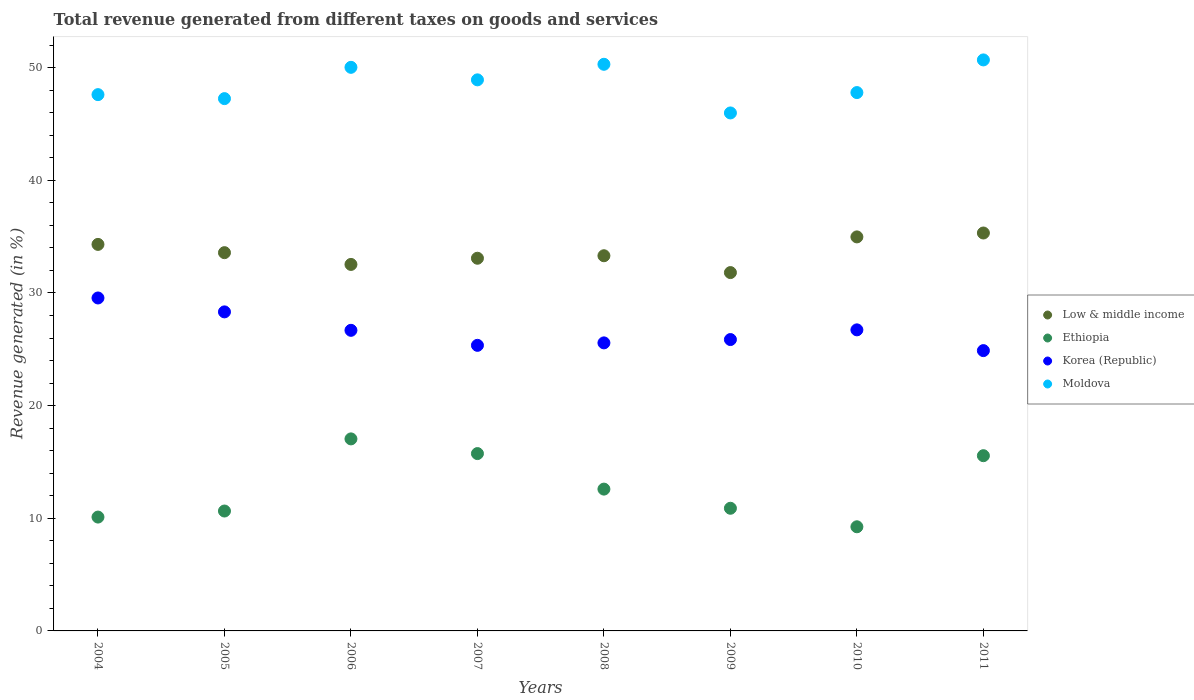What is the total revenue generated in Ethiopia in 2010?
Make the answer very short. 9.25. Across all years, what is the maximum total revenue generated in Low & middle income?
Your answer should be very brief. 35.33. Across all years, what is the minimum total revenue generated in Low & middle income?
Make the answer very short. 31.81. In which year was the total revenue generated in Low & middle income maximum?
Make the answer very short. 2011. What is the total total revenue generated in Ethiopia in the graph?
Your answer should be compact. 101.82. What is the difference between the total revenue generated in Korea (Republic) in 2006 and that in 2008?
Your response must be concise. 1.12. What is the difference between the total revenue generated in Low & middle income in 2008 and the total revenue generated in Korea (Republic) in 2007?
Provide a succinct answer. 7.95. What is the average total revenue generated in Ethiopia per year?
Your response must be concise. 12.73. In the year 2005, what is the difference between the total revenue generated in Low & middle income and total revenue generated in Korea (Republic)?
Offer a terse response. 5.26. What is the ratio of the total revenue generated in Korea (Republic) in 2009 to that in 2010?
Your response must be concise. 0.97. What is the difference between the highest and the second highest total revenue generated in Moldova?
Offer a very short reply. 0.39. What is the difference between the highest and the lowest total revenue generated in Ethiopia?
Provide a succinct answer. 7.8. Is it the case that in every year, the sum of the total revenue generated in Moldova and total revenue generated in Ethiopia  is greater than the sum of total revenue generated in Korea (Republic) and total revenue generated in Low & middle income?
Give a very brief answer. Yes. Is the total revenue generated in Ethiopia strictly greater than the total revenue generated in Moldova over the years?
Offer a very short reply. No. Is the total revenue generated in Ethiopia strictly less than the total revenue generated in Korea (Republic) over the years?
Provide a succinct answer. Yes. How many years are there in the graph?
Your response must be concise. 8. What is the difference between two consecutive major ticks on the Y-axis?
Provide a succinct answer. 10. What is the title of the graph?
Give a very brief answer. Total revenue generated from different taxes on goods and services. What is the label or title of the X-axis?
Your answer should be compact. Years. What is the label or title of the Y-axis?
Ensure brevity in your answer.  Revenue generated (in %). What is the Revenue generated (in %) of Low & middle income in 2004?
Your answer should be very brief. 34.31. What is the Revenue generated (in %) in Ethiopia in 2004?
Ensure brevity in your answer.  10.11. What is the Revenue generated (in %) in Korea (Republic) in 2004?
Offer a very short reply. 29.56. What is the Revenue generated (in %) of Moldova in 2004?
Give a very brief answer. 47.61. What is the Revenue generated (in %) of Low & middle income in 2005?
Provide a short and direct response. 33.58. What is the Revenue generated (in %) in Ethiopia in 2005?
Your answer should be compact. 10.64. What is the Revenue generated (in %) of Korea (Republic) in 2005?
Make the answer very short. 28.32. What is the Revenue generated (in %) of Moldova in 2005?
Offer a very short reply. 47.26. What is the Revenue generated (in %) in Low & middle income in 2006?
Your answer should be very brief. 32.54. What is the Revenue generated (in %) of Ethiopia in 2006?
Your answer should be very brief. 17.05. What is the Revenue generated (in %) of Korea (Republic) in 2006?
Ensure brevity in your answer.  26.69. What is the Revenue generated (in %) in Moldova in 2006?
Provide a succinct answer. 50.03. What is the Revenue generated (in %) of Low & middle income in 2007?
Provide a short and direct response. 33.08. What is the Revenue generated (in %) in Ethiopia in 2007?
Your answer should be very brief. 15.74. What is the Revenue generated (in %) of Korea (Republic) in 2007?
Offer a very short reply. 25.35. What is the Revenue generated (in %) in Moldova in 2007?
Your response must be concise. 48.92. What is the Revenue generated (in %) of Low & middle income in 2008?
Ensure brevity in your answer.  33.31. What is the Revenue generated (in %) of Ethiopia in 2008?
Offer a terse response. 12.59. What is the Revenue generated (in %) of Korea (Republic) in 2008?
Offer a terse response. 25.57. What is the Revenue generated (in %) in Moldova in 2008?
Provide a succinct answer. 50.3. What is the Revenue generated (in %) of Low & middle income in 2009?
Ensure brevity in your answer.  31.81. What is the Revenue generated (in %) of Ethiopia in 2009?
Your answer should be very brief. 10.89. What is the Revenue generated (in %) of Korea (Republic) in 2009?
Provide a short and direct response. 25.87. What is the Revenue generated (in %) in Moldova in 2009?
Your answer should be very brief. 45.98. What is the Revenue generated (in %) in Low & middle income in 2010?
Your response must be concise. 34.98. What is the Revenue generated (in %) in Ethiopia in 2010?
Give a very brief answer. 9.25. What is the Revenue generated (in %) of Korea (Republic) in 2010?
Keep it short and to the point. 26.73. What is the Revenue generated (in %) in Moldova in 2010?
Give a very brief answer. 47.79. What is the Revenue generated (in %) in Low & middle income in 2011?
Ensure brevity in your answer.  35.33. What is the Revenue generated (in %) in Ethiopia in 2011?
Offer a very short reply. 15.56. What is the Revenue generated (in %) of Korea (Republic) in 2011?
Give a very brief answer. 24.88. What is the Revenue generated (in %) in Moldova in 2011?
Ensure brevity in your answer.  50.69. Across all years, what is the maximum Revenue generated (in %) in Low & middle income?
Your response must be concise. 35.33. Across all years, what is the maximum Revenue generated (in %) of Ethiopia?
Provide a succinct answer. 17.05. Across all years, what is the maximum Revenue generated (in %) in Korea (Republic)?
Your answer should be very brief. 29.56. Across all years, what is the maximum Revenue generated (in %) of Moldova?
Offer a very short reply. 50.69. Across all years, what is the minimum Revenue generated (in %) of Low & middle income?
Offer a terse response. 31.81. Across all years, what is the minimum Revenue generated (in %) of Ethiopia?
Your answer should be very brief. 9.25. Across all years, what is the minimum Revenue generated (in %) of Korea (Republic)?
Your answer should be very brief. 24.88. Across all years, what is the minimum Revenue generated (in %) of Moldova?
Your response must be concise. 45.98. What is the total Revenue generated (in %) in Low & middle income in the graph?
Ensure brevity in your answer.  268.94. What is the total Revenue generated (in %) of Ethiopia in the graph?
Ensure brevity in your answer.  101.82. What is the total Revenue generated (in %) in Korea (Republic) in the graph?
Provide a succinct answer. 212.97. What is the total Revenue generated (in %) in Moldova in the graph?
Your answer should be compact. 388.59. What is the difference between the Revenue generated (in %) of Low & middle income in 2004 and that in 2005?
Keep it short and to the point. 0.73. What is the difference between the Revenue generated (in %) of Ethiopia in 2004 and that in 2005?
Provide a short and direct response. -0.54. What is the difference between the Revenue generated (in %) of Korea (Republic) in 2004 and that in 2005?
Offer a very short reply. 1.24. What is the difference between the Revenue generated (in %) in Moldova in 2004 and that in 2005?
Provide a short and direct response. 0.35. What is the difference between the Revenue generated (in %) of Low & middle income in 2004 and that in 2006?
Offer a terse response. 1.78. What is the difference between the Revenue generated (in %) of Ethiopia in 2004 and that in 2006?
Ensure brevity in your answer.  -6.94. What is the difference between the Revenue generated (in %) of Korea (Republic) in 2004 and that in 2006?
Give a very brief answer. 2.87. What is the difference between the Revenue generated (in %) of Moldova in 2004 and that in 2006?
Your response must be concise. -2.42. What is the difference between the Revenue generated (in %) of Low & middle income in 2004 and that in 2007?
Ensure brevity in your answer.  1.23. What is the difference between the Revenue generated (in %) of Ethiopia in 2004 and that in 2007?
Provide a short and direct response. -5.64. What is the difference between the Revenue generated (in %) in Korea (Republic) in 2004 and that in 2007?
Your answer should be compact. 4.21. What is the difference between the Revenue generated (in %) in Moldova in 2004 and that in 2007?
Ensure brevity in your answer.  -1.31. What is the difference between the Revenue generated (in %) in Ethiopia in 2004 and that in 2008?
Provide a succinct answer. -2.48. What is the difference between the Revenue generated (in %) of Korea (Republic) in 2004 and that in 2008?
Provide a short and direct response. 3.99. What is the difference between the Revenue generated (in %) of Moldova in 2004 and that in 2008?
Offer a very short reply. -2.69. What is the difference between the Revenue generated (in %) in Low & middle income in 2004 and that in 2009?
Give a very brief answer. 2.5. What is the difference between the Revenue generated (in %) in Ethiopia in 2004 and that in 2009?
Offer a terse response. -0.78. What is the difference between the Revenue generated (in %) of Korea (Republic) in 2004 and that in 2009?
Your answer should be compact. 3.69. What is the difference between the Revenue generated (in %) in Moldova in 2004 and that in 2009?
Your response must be concise. 1.63. What is the difference between the Revenue generated (in %) of Low & middle income in 2004 and that in 2010?
Offer a terse response. -0.67. What is the difference between the Revenue generated (in %) of Ethiopia in 2004 and that in 2010?
Provide a succinct answer. 0.86. What is the difference between the Revenue generated (in %) of Korea (Republic) in 2004 and that in 2010?
Your response must be concise. 2.83. What is the difference between the Revenue generated (in %) of Moldova in 2004 and that in 2010?
Offer a terse response. -0.18. What is the difference between the Revenue generated (in %) of Low & middle income in 2004 and that in 2011?
Your answer should be compact. -1.01. What is the difference between the Revenue generated (in %) of Ethiopia in 2004 and that in 2011?
Your response must be concise. -5.45. What is the difference between the Revenue generated (in %) of Korea (Republic) in 2004 and that in 2011?
Ensure brevity in your answer.  4.67. What is the difference between the Revenue generated (in %) in Moldova in 2004 and that in 2011?
Provide a short and direct response. -3.08. What is the difference between the Revenue generated (in %) of Low & middle income in 2005 and that in 2006?
Make the answer very short. 1.04. What is the difference between the Revenue generated (in %) of Ethiopia in 2005 and that in 2006?
Give a very brief answer. -6.4. What is the difference between the Revenue generated (in %) of Korea (Republic) in 2005 and that in 2006?
Offer a very short reply. 1.64. What is the difference between the Revenue generated (in %) in Moldova in 2005 and that in 2006?
Provide a short and direct response. -2.78. What is the difference between the Revenue generated (in %) of Low & middle income in 2005 and that in 2007?
Offer a very short reply. 0.5. What is the difference between the Revenue generated (in %) of Ethiopia in 2005 and that in 2007?
Give a very brief answer. -5.1. What is the difference between the Revenue generated (in %) in Korea (Republic) in 2005 and that in 2007?
Your answer should be very brief. 2.97. What is the difference between the Revenue generated (in %) in Moldova in 2005 and that in 2007?
Offer a terse response. -1.67. What is the difference between the Revenue generated (in %) of Low & middle income in 2005 and that in 2008?
Provide a short and direct response. 0.27. What is the difference between the Revenue generated (in %) of Ethiopia in 2005 and that in 2008?
Keep it short and to the point. -1.95. What is the difference between the Revenue generated (in %) in Korea (Republic) in 2005 and that in 2008?
Your answer should be very brief. 2.75. What is the difference between the Revenue generated (in %) of Moldova in 2005 and that in 2008?
Provide a short and direct response. -3.05. What is the difference between the Revenue generated (in %) of Low & middle income in 2005 and that in 2009?
Give a very brief answer. 1.77. What is the difference between the Revenue generated (in %) in Ethiopia in 2005 and that in 2009?
Provide a short and direct response. -0.25. What is the difference between the Revenue generated (in %) in Korea (Republic) in 2005 and that in 2009?
Provide a succinct answer. 2.46. What is the difference between the Revenue generated (in %) in Moldova in 2005 and that in 2009?
Your answer should be compact. 1.27. What is the difference between the Revenue generated (in %) in Low & middle income in 2005 and that in 2010?
Offer a terse response. -1.4. What is the difference between the Revenue generated (in %) in Ethiopia in 2005 and that in 2010?
Ensure brevity in your answer.  1.4. What is the difference between the Revenue generated (in %) in Korea (Republic) in 2005 and that in 2010?
Make the answer very short. 1.6. What is the difference between the Revenue generated (in %) of Moldova in 2005 and that in 2010?
Make the answer very short. -0.54. What is the difference between the Revenue generated (in %) of Low & middle income in 2005 and that in 2011?
Provide a succinct answer. -1.75. What is the difference between the Revenue generated (in %) of Ethiopia in 2005 and that in 2011?
Provide a short and direct response. -4.91. What is the difference between the Revenue generated (in %) of Korea (Republic) in 2005 and that in 2011?
Your answer should be compact. 3.44. What is the difference between the Revenue generated (in %) of Moldova in 2005 and that in 2011?
Offer a terse response. -3.44. What is the difference between the Revenue generated (in %) of Low & middle income in 2006 and that in 2007?
Provide a short and direct response. -0.55. What is the difference between the Revenue generated (in %) of Ethiopia in 2006 and that in 2007?
Keep it short and to the point. 1.3. What is the difference between the Revenue generated (in %) of Korea (Republic) in 2006 and that in 2007?
Make the answer very short. 1.33. What is the difference between the Revenue generated (in %) in Moldova in 2006 and that in 2007?
Your response must be concise. 1.11. What is the difference between the Revenue generated (in %) in Low & middle income in 2006 and that in 2008?
Make the answer very short. -0.77. What is the difference between the Revenue generated (in %) in Ethiopia in 2006 and that in 2008?
Your answer should be very brief. 4.46. What is the difference between the Revenue generated (in %) in Korea (Republic) in 2006 and that in 2008?
Make the answer very short. 1.12. What is the difference between the Revenue generated (in %) in Moldova in 2006 and that in 2008?
Provide a short and direct response. -0.27. What is the difference between the Revenue generated (in %) of Low & middle income in 2006 and that in 2009?
Give a very brief answer. 0.72. What is the difference between the Revenue generated (in %) in Ethiopia in 2006 and that in 2009?
Keep it short and to the point. 6.16. What is the difference between the Revenue generated (in %) of Korea (Republic) in 2006 and that in 2009?
Make the answer very short. 0.82. What is the difference between the Revenue generated (in %) in Moldova in 2006 and that in 2009?
Provide a short and direct response. 4.05. What is the difference between the Revenue generated (in %) of Low & middle income in 2006 and that in 2010?
Your answer should be compact. -2.44. What is the difference between the Revenue generated (in %) of Ethiopia in 2006 and that in 2010?
Make the answer very short. 7.8. What is the difference between the Revenue generated (in %) in Korea (Republic) in 2006 and that in 2010?
Your answer should be compact. -0.04. What is the difference between the Revenue generated (in %) in Moldova in 2006 and that in 2010?
Your answer should be very brief. 2.24. What is the difference between the Revenue generated (in %) of Low & middle income in 2006 and that in 2011?
Make the answer very short. -2.79. What is the difference between the Revenue generated (in %) in Ethiopia in 2006 and that in 2011?
Offer a terse response. 1.49. What is the difference between the Revenue generated (in %) in Korea (Republic) in 2006 and that in 2011?
Offer a very short reply. 1.8. What is the difference between the Revenue generated (in %) in Moldova in 2006 and that in 2011?
Make the answer very short. -0.66. What is the difference between the Revenue generated (in %) in Low & middle income in 2007 and that in 2008?
Ensure brevity in your answer.  -0.22. What is the difference between the Revenue generated (in %) in Ethiopia in 2007 and that in 2008?
Make the answer very short. 3.15. What is the difference between the Revenue generated (in %) of Korea (Republic) in 2007 and that in 2008?
Your answer should be very brief. -0.22. What is the difference between the Revenue generated (in %) of Moldova in 2007 and that in 2008?
Make the answer very short. -1.38. What is the difference between the Revenue generated (in %) in Low & middle income in 2007 and that in 2009?
Offer a very short reply. 1.27. What is the difference between the Revenue generated (in %) of Ethiopia in 2007 and that in 2009?
Your answer should be very brief. 4.85. What is the difference between the Revenue generated (in %) of Korea (Republic) in 2007 and that in 2009?
Offer a very short reply. -0.51. What is the difference between the Revenue generated (in %) of Moldova in 2007 and that in 2009?
Your response must be concise. 2.94. What is the difference between the Revenue generated (in %) of Low & middle income in 2007 and that in 2010?
Your response must be concise. -1.89. What is the difference between the Revenue generated (in %) in Ethiopia in 2007 and that in 2010?
Offer a very short reply. 6.5. What is the difference between the Revenue generated (in %) of Korea (Republic) in 2007 and that in 2010?
Your answer should be very brief. -1.37. What is the difference between the Revenue generated (in %) in Moldova in 2007 and that in 2010?
Your answer should be very brief. 1.13. What is the difference between the Revenue generated (in %) of Low & middle income in 2007 and that in 2011?
Offer a terse response. -2.24. What is the difference between the Revenue generated (in %) of Ethiopia in 2007 and that in 2011?
Provide a succinct answer. 0.19. What is the difference between the Revenue generated (in %) of Korea (Republic) in 2007 and that in 2011?
Your answer should be very brief. 0.47. What is the difference between the Revenue generated (in %) in Moldova in 2007 and that in 2011?
Your response must be concise. -1.77. What is the difference between the Revenue generated (in %) of Low & middle income in 2008 and that in 2009?
Your answer should be compact. 1.49. What is the difference between the Revenue generated (in %) in Ethiopia in 2008 and that in 2009?
Offer a very short reply. 1.7. What is the difference between the Revenue generated (in %) in Korea (Republic) in 2008 and that in 2009?
Your response must be concise. -0.3. What is the difference between the Revenue generated (in %) in Moldova in 2008 and that in 2009?
Your answer should be very brief. 4.32. What is the difference between the Revenue generated (in %) of Low & middle income in 2008 and that in 2010?
Your answer should be very brief. -1.67. What is the difference between the Revenue generated (in %) in Ethiopia in 2008 and that in 2010?
Your response must be concise. 3.34. What is the difference between the Revenue generated (in %) in Korea (Republic) in 2008 and that in 2010?
Provide a succinct answer. -1.16. What is the difference between the Revenue generated (in %) in Moldova in 2008 and that in 2010?
Ensure brevity in your answer.  2.51. What is the difference between the Revenue generated (in %) of Low & middle income in 2008 and that in 2011?
Provide a succinct answer. -2.02. What is the difference between the Revenue generated (in %) of Ethiopia in 2008 and that in 2011?
Ensure brevity in your answer.  -2.97. What is the difference between the Revenue generated (in %) in Korea (Republic) in 2008 and that in 2011?
Offer a very short reply. 0.69. What is the difference between the Revenue generated (in %) of Moldova in 2008 and that in 2011?
Your answer should be very brief. -0.39. What is the difference between the Revenue generated (in %) in Low & middle income in 2009 and that in 2010?
Offer a terse response. -3.17. What is the difference between the Revenue generated (in %) of Ethiopia in 2009 and that in 2010?
Provide a succinct answer. 1.64. What is the difference between the Revenue generated (in %) of Korea (Republic) in 2009 and that in 2010?
Make the answer very short. -0.86. What is the difference between the Revenue generated (in %) in Moldova in 2009 and that in 2010?
Keep it short and to the point. -1.81. What is the difference between the Revenue generated (in %) of Low & middle income in 2009 and that in 2011?
Your answer should be very brief. -3.51. What is the difference between the Revenue generated (in %) of Ethiopia in 2009 and that in 2011?
Make the answer very short. -4.67. What is the difference between the Revenue generated (in %) of Korea (Republic) in 2009 and that in 2011?
Your response must be concise. 0.98. What is the difference between the Revenue generated (in %) in Moldova in 2009 and that in 2011?
Provide a succinct answer. -4.71. What is the difference between the Revenue generated (in %) in Low & middle income in 2010 and that in 2011?
Ensure brevity in your answer.  -0.35. What is the difference between the Revenue generated (in %) of Ethiopia in 2010 and that in 2011?
Offer a very short reply. -6.31. What is the difference between the Revenue generated (in %) in Korea (Republic) in 2010 and that in 2011?
Offer a terse response. 1.84. What is the difference between the Revenue generated (in %) in Moldova in 2010 and that in 2011?
Provide a succinct answer. -2.9. What is the difference between the Revenue generated (in %) in Low & middle income in 2004 and the Revenue generated (in %) in Ethiopia in 2005?
Offer a very short reply. 23.67. What is the difference between the Revenue generated (in %) in Low & middle income in 2004 and the Revenue generated (in %) in Korea (Republic) in 2005?
Your answer should be compact. 5.99. What is the difference between the Revenue generated (in %) in Low & middle income in 2004 and the Revenue generated (in %) in Moldova in 2005?
Your response must be concise. -12.94. What is the difference between the Revenue generated (in %) of Ethiopia in 2004 and the Revenue generated (in %) of Korea (Republic) in 2005?
Offer a very short reply. -18.22. What is the difference between the Revenue generated (in %) of Ethiopia in 2004 and the Revenue generated (in %) of Moldova in 2005?
Give a very brief answer. -37.15. What is the difference between the Revenue generated (in %) of Korea (Republic) in 2004 and the Revenue generated (in %) of Moldova in 2005?
Your answer should be very brief. -17.7. What is the difference between the Revenue generated (in %) of Low & middle income in 2004 and the Revenue generated (in %) of Ethiopia in 2006?
Your answer should be very brief. 17.27. What is the difference between the Revenue generated (in %) in Low & middle income in 2004 and the Revenue generated (in %) in Korea (Republic) in 2006?
Offer a very short reply. 7.63. What is the difference between the Revenue generated (in %) in Low & middle income in 2004 and the Revenue generated (in %) in Moldova in 2006?
Provide a short and direct response. -15.72. What is the difference between the Revenue generated (in %) of Ethiopia in 2004 and the Revenue generated (in %) of Korea (Republic) in 2006?
Your answer should be compact. -16.58. What is the difference between the Revenue generated (in %) in Ethiopia in 2004 and the Revenue generated (in %) in Moldova in 2006?
Offer a terse response. -39.93. What is the difference between the Revenue generated (in %) in Korea (Republic) in 2004 and the Revenue generated (in %) in Moldova in 2006?
Provide a succinct answer. -20.48. What is the difference between the Revenue generated (in %) in Low & middle income in 2004 and the Revenue generated (in %) in Ethiopia in 2007?
Your response must be concise. 18.57. What is the difference between the Revenue generated (in %) of Low & middle income in 2004 and the Revenue generated (in %) of Korea (Republic) in 2007?
Your response must be concise. 8.96. What is the difference between the Revenue generated (in %) of Low & middle income in 2004 and the Revenue generated (in %) of Moldova in 2007?
Your response must be concise. -14.61. What is the difference between the Revenue generated (in %) in Ethiopia in 2004 and the Revenue generated (in %) in Korea (Republic) in 2007?
Offer a terse response. -15.25. What is the difference between the Revenue generated (in %) in Ethiopia in 2004 and the Revenue generated (in %) in Moldova in 2007?
Offer a terse response. -38.82. What is the difference between the Revenue generated (in %) in Korea (Republic) in 2004 and the Revenue generated (in %) in Moldova in 2007?
Ensure brevity in your answer.  -19.36. What is the difference between the Revenue generated (in %) in Low & middle income in 2004 and the Revenue generated (in %) in Ethiopia in 2008?
Your answer should be compact. 21.72. What is the difference between the Revenue generated (in %) in Low & middle income in 2004 and the Revenue generated (in %) in Korea (Republic) in 2008?
Your response must be concise. 8.74. What is the difference between the Revenue generated (in %) of Low & middle income in 2004 and the Revenue generated (in %) of Moldova in 2008?
Your response must be concise. -15.99. What is the difference between the Revenue generated (in %) in Ethiopia in 2004 and the Revenue generated (in %) in Korea (Republic) in 2008?
Offer a very short reply. -15.46. What is the difference between the Revenue generated (in %) in Ethiopia in 2004 and the Revenue generated (in %) in Moldova in 2008?
Keep it short and to the point. -40.2. What is the difference between the Revenue generated (in %) of Korea (Republic) in 2004 and the Revenue generated (in %) of Moldova in 2008?
Make the answer very short. -20.74. What is the difference between the Revenue generated (in %) of Low & middle income in 2004 and the Revenue generated (in %) of Ethiopia in 2009?
Your answer should be very brief. 23.42. What is the difference between the Revenue generated (in %) of Low & middle income in 2004 and the Revenue generated (in %) of Korea (Republic) in 2009?
Ensure brevity in your answer.  8.45. What is the difference between the Revenue generated (in %) of Low & middle income in 2004 and the Revenue generated (in %) of Moldova in 2009?
Provide a short and direct response. -11.67. What is the difference between the Revenue generated (in %) in Ethiopia in 2004 and the Revenue generated (in %) in Korea (Republic) in 2009?
Your answer should be very brief. -15.76. What is the difference between the Revenue generated (in %) in Ethiopia in 2004 and the Revenue generated (in %) in Moldova in 2009?
Ensure brevity in your answer.  -35.88. What is the difference between the Revenue generated (in %) of Korea (Republic) in 2004 and the Revenue generated (in %) of Moldova in 2009?
Offer a terse response. -16.43. What is the difference between the Revenue generated (in %) in Low & middle income in 2004 and the Revenue generated (in %) in Ethiopia in 2010?
Your response must be concise. 25.07. What is the difference between the Revenue generated (in %) in Low & middle income in 2004 and the Revenue generated (in %) in Korea (Republic) in 2010?
Provide a succinct answer. 7.59. What is the difference between the Revenue generated (in %) in Low & middle income in 2004 and the Revenue generated (in %) in Moldova in 2010?
Provide a succinct answer. -13.48. What is the difference between the Revenue generated (in %) in Ethiopia in 2004 and the Revenue generated (in %) in Korea (Republic) in 2010?
Make the answer very short. -16.62. What is the difference between the Revenue generated (in %) of Ethiopia in 2004 and the Revenue generated (in %) of Moldova in 2010?
Provide a succinct answer. -37.69. What is the difference between the Revenue generated (in %) in Korea (Republic) in 2004 and the Revenue generated (in %) in Moldova in 2010?
Provide a succinct answer. -18.23. What is the difference between the Revenue generated (in %) in Low & middle income in 2004 and the Revenue generated (in %) in Ethiopia in 2011?
Your answer should be very brief. 18.76. What is the difference between the Revenue generated (in %) in Low & middle income in 2004 and the Revenue generated (in %) in Korea (Republic) in 2011?
Your answer should be compact. 9.43. What is the difference between the Revenue generated (in %) of Low & middle income in 2004 and the Revenue generated (in %) of Moldova in 2011?
Keep it short and to the point. -16.38. What is the difference between the Revenue generated (in %) of Ethiopia in 2004 and the Revenue generated (in %) of Korea (Republic) in 2011?
Keep it short and to the point. -14.78. What is the difference between the Revenue generated (in %) of Ethiopia in 2004 and the Revenue generated (in %) of Moldova in 2011?
Offer a very short reply. -40.58. What is the difference between the Revenue generated (in %) of Korea (Republic) in 2004 and the Revenue generated (in %) of Moldova in 2011?
Provide a short and direct response. -21.13. What is the difference between the Revenue generated (in %) in Low & middle income in 2005 and the Revenue generated (in %) in Ethiopia in 2006?
Offer a terse response. 16.53. What is the difference between the Revenue generated (in %) in Low & middle income in 2005 and the Revenue generated (in %) in Korea (Republic) in 2006?
Keep it short and to the point. 6.89. What is the difference between the Revenue generated (in %) of Low & middle income in 2005 and the Revenue generated (in %) of Moldova in 2006?
Provide a succinct answer. -16.45. What is the difference between the Revenue generated (in %) of Ethiopia in 2005 and the Revenue generated (in %) of Korea (Republic) in 2006?
Your response must be concise. -16.04. What is the difference between the Revenue generated (in %) of Ethiopia in 2005 and the Revenue generated (in %) of Moldova in 2006?
Offer a very short reply. -39.39. What is the difference between the Revenue generated (in %) of Korea (Republic) in 2005 and the Revenue generated (in %) of Moldova in 2006?
Ensure brevity in your answer.  -21.71. What is the difference between the Revenue generated (in %) in Low & middle income in 2005 and the Revenue generated (in %) in Ethiopia in 2007?
Ensure brevity in your answer.  17.84. What is the difference between the Revenue generated (in %) of Low & middle income in 2005 and the Revenue generated (in %) of Korea (Republic) in 2007?
Your answer should be very brief. 8.23. What is the difference between the Revenue generated (in %) of Low & middle income in 2005 and the Revenue generated (in %) of Moldova in 2007?
Offer a terse response. -15.34. What is the difference between the Revenue generated (in %) in Ethiopia in 2005 and the Revenue generated (in %) in Korea (Republic) in 2007?
Offer a very short reply. -14.71. What is the difference between the Revenue generated (in %) in Ethiopia in 2005 and the Revenue generated (in %) in Moldova in 2007?
Ensure brevity in your answer.  -38.28. What is the difference between the Revenue generated (in %) of Korea (Republic) in 2005 and the Revenue generated (in %) of Moldova in 2007?
Offer a terse response. -20.6. What is the difference between the Revenue generated (in %) in Low & middle income in 2005 and the Revenue generated (in %) in Ethiopia in 2008?
Offer a terse response. 20.99. What is the difference between the Revenue generated (in %) in Low & middle income in 2005 and the Revenue generated (in %) in Korea (Republic) in 2008?
Your answer should be very brief. 8.01. What is the difference between the Revenue generated (in %) in Low & middle income in 2005 and the Revenue generated (in %) in Moldova in 2008?
Make the answer very short. -16.72. What is the difference between the Revenue generated (in %) in Ethiopia in 2005 and the Revenue generated (in %) in Korea (Republic) in 2008?
Keep it short and to the point. -14.93. What is the difference between the Revenue generated (in %) in Ethiopia in 2005 and the Revenue generated (in %) in Moldova in 2008?
Your response must be concise. -39.66. What is the difference between the Revenue generated (in %) in Korea (Republic) in 2005 and the Revenue generated (in %) in Moldova in 2008?
Your answer should be very brief. -21.98. What is the difference between the Revenue generated (in %) in Low & middle income in 2005 and the Revenue generated (in %) in Ethiopia in 2009?
Your response must be concise. 22.69. What is the difference between the Revenue generated (in %) in Low & middle income in 2005 and the Revenue generated (in %) in Korea (Republic) in 2009?
Your response must be concise. 7.71. What is the difference between the Revenue generated (in %) in Low & middle income in 2005 and the Revenue generated (in %) in Moldova in 2009?
Keep it short and to the point. -12.4. What is the difference between the Revenue generated (in %) in Ethiopia in 2005 and the Revenue generated (in %) in Korea (Republic) in 2009?
Make the answer very short. -15.22. What is the difference between the Revenue generated (in %) in Ethiopia in 2005 and the Revenue generated (in %) in Moldova in 2009?
Offer a very short reply. -35.34. What is the difference between the Revenue generated (in %) of Korea (Republic) in 2005 and the Revenue generated (in %) of Moldova in 2009?
Ensure brevity in your answer.  -17.66. What is the difference between the Revenue generated (in %) in Low & middle income in 2005 and the Revenue generated (in %) in Ethiopia in 2010?
Ensure brevity in your answer.  24.33. What is the difference between the Revenue generated (in %) of Low & middle income in 2005 and the Revenue generated (in %) of Korea (Republic) in 2010?
Provide a short and direct response. 6.85. What is the difference between the Revenue generated (in %) of Low & middle income in 2005 and the Revenue generated (in %) of Moldova in 2010?
Offer a very short reply. -14.21. What is the difference between the Revenue generated (in %) of Ethiopia in 2005 and the Revenue generated (in %) of Korea (Republic) in 2010?
Your answer should be compact. -16.08. What is the difference between the Revenue generated (in %) of Ethiopia in 2005 and the Revenue generated (in %) of Moldova in 2010?
Offer a very short reply. -37.15. What is the difference between the Revenue generated (in %) in Korea (Republic) in 2005 and the Revenue generated (in %) in Moldova in 2010?
Your response must be concise. -19.47. What is the difference between the Revenue generated (in %) in Low & middle income in 2005 and the Revenue generated (in %) in Ethiopia in 2011?
Provide a short and direct response. 18.02. What is the difference between the Revenue generated (in %) in Low & middle income in 2005 and the Revenue generated (in %) in Korea (Republic) in 2011?
Give a very brief answer. 8.7. What is the difference between the Revenue generated (in %) of Low & middle income in 2005 and the Revenue generated (in %) of Moldova in 2011?
Your answer should be compact. -17.11. What is the difference between the Revenue generated (in %) in Ethiopia in 2005 and the Revenue generated (in %) in Korea (Republic) in 2011?
Give a very brief answer. -14.24. What is the difference between the Revenue generated (in %) in Ethiopia in 2005 and the Revenue generated (in %) in Moldova in 2011?
Your response must be concise. -40.05. What is the difference between the Revenue generated (in %) of Korea (Republic) in 2005 and the Revenue generated (in %) of Moldova in 2011?
Your response must be concise. -22.37. What is the difference between the Revenue generated (in %) of Low & middle income in 2006 and the Revenue generated (in %) of Ethiopia in 2007?
Your answer should be very brief. 16.79. What is the difference between the Revenue generated (in %) of Low & middle income in 2006 and the Revenue generated (in %) of Korea (Republic) in 2007?
Keep it short and to the point. 7.18. What is the difference between the Revenue generated (in %) in Low & middle income in 2006 and the Revenue generated (in %) in Moldova in 2007?
Keep it short and to the point. -16.39. What is the difference between the Revenue generated (in %) in Ethiopia in 2006 and the Revenue generated (in %) in Korea (Republic) in 2007?
Your answer should be very brief. -8.31. What is the difference between the Revenue generated (in %) in Ethiopia in 2006 and the Revenue generated (in %) in Moldova in 2007?
Your answer should be compact. -31.87. What is the difference between the Revenue generated (in %) of Korea (Republic) in 2006 and the Revenue generated (in %) of Moldova in 2007?
Provide a short and direct response. -22.24. What is the difference between the Revenue generated (in %) of Low & middle income in 2006 and the Revenue generated (in %) of Ethiopia in 2008?
Give a very brief answer. 19.95. What is the difference between the Revenue generated (in %) of Low & middle income in 2006 and the Revenue generated (in %) of Korea (Republic) in 2008?
Offer a terse response. 6.96. What is the difference between the Revenue generated (in %) of Low & middle income in 2006 and the Revenue generated (in %) of Moldova in 2008?
Your answer should be compact. -17.77. What is the difference between the Revenue generated (in %) of Ethiopia in 2006 and the Revenue generated (in %) of Korea (Republic) in 2008?
Your answer should be very brief. -8.52. What is the difference between the Revenue generated (in %) in Ethiopia in 2006 and the Revenue generated (in %) in Moldova in 2008?
Give a very brief answer. -33.26. What is the difference between the Revenue generated (in %) of Korea (Republic) in 2006 and the Revenue generated (in %) of Moldova in 2008?
Ensure brevity in your answer.  -23.62. What is the difference between the Revenue generated (in %) in Low & middle income in 2006 and the Revenue generated (in %) in Ethiopia in 2009?
Your answer should be very brief. 21.65. What is the difference between the Revenue generated (in %) in Low & middle income in 2006 and the Revenue generated (in %) in Korea (Republic) in 2009?
Give a very brief answer. 6.67. What is the difference between the Revenue generated (in %) of Low & middle income in 2006 and the Revenue generated (in %) of Moldova in 2009?
Offer a very short reply. -13.45. What is the difference between the Revenue generated (in %) of Ethiopia in 2006 and the Revenue generated (in %) of Korea (Republic) in 2009?
Keep it short and to the point. -8.82. What is the difference between the Revenue generated (in %) in Ethiopia in 2006 and the Revenue generated (in %) in Moldova in 2009?
Your response must be concise. -28.94. What is the difference between the Revenue generated (in %) in Korea (Republic) in 2006 and the Revenue generated (in %) in Moldova in 2009?
Your answer should be compact. -19.3. What is the difference between the Revenue generated (in %) in Low & middle income in 2006 and the Revenue generated (in %) in Ethiopia in 2010?
Provide a short and direct response. 23.29. What is the difference between the Revenue generated (in %) of Low & middle income in 2006 and the Revenue generated (in %) of Korea (Republic) in 2010?
Provide a succinct answer. 5.81. What is the difference between the Revenue generated (in %) in Low & middle income in 2006 and the Revenue generated (in %) in Moldova in 2010?
Provide a short and direct response. -15.26. What is the difference between the Revenue generated (in %) of Ethiopia in 2006 and the Revenue generated (in %) of Korea (Republic) in 2010?
Provide a short and direct response. -9.68. What is the difference between the Revenue generated (in %) in Ethiopia in 2006 and the Revenue generated (in %) in Moldova in 2010?
Your response must be concise. -30.74. What is the difference between the Revenue generated (in %) in Korea (Republic) in 2006 and the Revenue generated (in %) in Moldova in 2010?
Your response must be concise. -21.11. What is the difference between the Revenue generated (in %) in Low & middle income in 2006 and the Revenue generated (in %) in Ethiopia in 2011?
Give a very brief answer. 16.98. What is the difference between the Revenue generated (in %) in Low & middle income in 2006 and the Revenue generated (in %) in Korea (Republic) in 2011?
Your response must be concise. 7.65. What is the difference between the Revenue generated (in %) in Low & middle income in 2006 and the Revenue generated (in %) in Moldova in 2011?
Provide a succinct answer. -18.16. What is the difference between the Revenue generated (in %) in Ethiopia in 2006 and the Revenue generated (in %) in Korea (Republic) in 2011?
Offer a very short reply. -7.84. What is the difference between the Revenue generated (in %) of Ethiopia in 2006 and the Revenue generated (in %) of Moldova in 2011?
Offer a terse response. -33.64. What is the difference between the Revenue generated (in %) in Korea (Republic) in 2006 and the Revenue generated (in %) in Moldova in 2011?
Offer a very short reply. -24. What is the difference between the Revenue generated (in %) in Low & middle income in 2007 and the Revenue generated (in %) in Ethiopia in 2008?
Provide a succinct answer. 20.5. What is the difference between the Revenue generated (in %) in Low & middle income in 2007 and the Revenue generated (in %) in Korea (Republic) in 2008?
Provide a short and direct response. 7.51. What is the difference between the Revenue generated (in %) in Low & middle income in 2007 and the Revenue generated (in %) in Moldova in 2008?
Your answer should be compact. -17.22. What is the difference between the Revenue generated (in %) in Ethiopia in 2007 and the Revenue generated (in %) in Korea (Republic) in 2008?
Offer a terse response. -9.83. What is the difference between the Revenue generated (in %) in Ethiopia in 2007 and the Revenue generated (in %) in Moldova in 2008?
Your response must be concise. -34.56. What is the difference between the Revenue generated (in %) in Korea (Republic) in 2007 and the Revenue generated (in %) in Moldova in 2008?
Keep it short and to the point. -24.95. What is the difference between the Revenue generated (in %) in Low & middle income in 2007 and the Revenue generated (in %) in Ethiopia in 2009?
Your answer should be compact. 22.2. What is the difference between the Revenue generated (in %) in Low & middle income in 2007 and the Revenue generated (in %) in Korea (Republic) in 2009?
Make the answer very short. 7.22. What is the difference between the Revenue generated (in %) in Low & middle income in 2007 and the Revenue generated (in %) in Moldova in 2009?
Ensure brevity in your answer.  -12.9. What is the difference between the Revenue generated (in %) of Ethiopia in 2007 and the Revenue generated (in %) of Korea (Republic) in 2009?
Offer a terse response. -10.12. What is the difference between the Revenue generated (in %) in Ethiopia in 2007 and the Revenue generated (in %) in Moldova in 2009?
Offer a very short reply. -30.24. What is the difference between the Revenue generated (in %) in Korea (Republic) in 2007 and the Revenue generated (in %) in Moldova in 2009?
Your answer should be very brief. -20.63. What is the difference between the Revenue generated (in %) in Low & middle income in 2007 and the Revenue generated (in %) in Ethiopia in 2010?
Offer a terse response. 23.84. What is the difference between the Revenue generated (in %) of Low & middle income in 2007 and the Revenue generated (in %) of Korea (Republic) in 2010?
Ensure brevity in your answer.  6.36. What is the difference between the Revenue generated (in %) of Low & middle income in 2007 and the Revenue generated (in %) of Moldova in 2010?
Your response must be concise. -14.71. What is the difference between the Revenue generated (in %) in Ethiopia in 2007 and the Revenue generated (in %) in Korea (Republic) in 2010?
Your answer should be compact. -10.98. What is the difference between the Revenue generated (in %) of Ethiopia in 2007 and the Revenue generated (in %) of Moldova in 2010?
Ensure brevity in your answer.  -32.05. What is the difference between the Revenue generated (in %) in Korea (Republic) in 2007 and the Revenue generated (in %) in Moldova in 2010?
Offer a very short reply. -22.44. What is the difference between the Revenue generated (in %) of Low & middle income in 2007 and the Revenue generated (in %) of Ethiopia in 2011?
Your response must be concise. 17.53. What is the difference between the Revenue generated (in %) of Low & middle income in 2007 and the Revenue generated (in %) of Korea (Republic) in 2011?
Provide a succinct answer. 8.2. What is the difference between the Revenue generated (in %) of Low & middle income in 2007 and the Revenue generated (in %) of Moldova in 2011?
Your response must be concise. -17.61. What is the difference between the Revenue generated (in %) in Ethiopia in 2007 and the Revenue generated (in %) in Korea (Republic) in 2011?
Provide a succinct answer. -9.14. What is the difference between the Revenue generated (in %) in Ethiopia in 2007 and the Revenue generated (in %) in Moldova in 2011?
Offer a terse response. -34.95. What is the difference between the Revenue generated (in %) in Korea (Republic) in 2007 and the Revenue generated (in %) in Moldova in 2011?
Offer a terse response. -25.34. What is the difference between the Revenue generated (in %) of Low & middle income in 2008 and the Revenue generated (in %) of Ethiopia in 2009?
Give a very brief answer. 22.42. What is the difference between the Revenue generated (in %) in Low & middle income in 2008 and the Revenue generated (in %) in Korea (Republic) in 2009?
Give a very brief answer. 7.44. What is the difference between the Revenue generated (in %) in Low & middle income in 2008 and the Revenue generated (in %) in Moldova in 2009?
Give a very brief answer. -12.68. What is the difference between the Revenue generated (in %) of Ethiopia in 2008 and the Revenue generated (in %) of Korea (Republic) in 2009?
Offer a terse response. -13.28. What is the difference between the Revenue generated (in %) of Ethiopia in 2008 and the Revenue generated (in %) of Moldova in 2009?
Provide a short and direct response. -33.39. What is the difference between the Revenue generated (in %) in Korea (Republic) in 2008 and the Revenue generated (in %) in Moldova in 2009?
Give a very brief answer. -20.41. What is the difference between the Revenue generated (in %) in Low & middle income in 2008 and the Revenue generated (in %) in Ethiopia in 2010?
Your answer should be very brief. 24.06. What is the difference between the Revenue generated (in %) in Low & middle income in 2008 and the Revenue generated (in %) in Korea (Republic) in 2010?
Provide a short and direct response. 6.58. What is the difference between the Revenue generated (in %) of Low & middle income in 2008 and the Revenue generated (in %) of Moldova in 2010?
Your answer should be very brief. -14.49. What is the difference between the Revenue generated (in %) in Ethiopia in 2008 and the Revenue generated (in %) in Korea (Republic) in 2010?
Make the answer very short. -14.14. What is the difference between the Revenue generated (in %) in Ethiopia in 2008 and the Revenue generated (in %) in Moldova in 2010?
Keep it short and to the point. -35.2. What is the difference between the Revenue generated (in %) in Korea (Republic) in 2008 and the Revenue generated (in %) in Moldova in 2010?
Your answer should be compact. -22.22. What is the difference between the Revenue generated (in %) of Low & middle income in 2008 and the Revenue generated (in %) of Ethiopia in 2011?
Offer a terse response. 17.75. What is the difference between the Revenue generated (in %) of Low & middle income in 2008 and the Revenue generated (in %) of Korea (Republic) in 2011?
Provide a short and direct response. 8.42. What is the difference between the Revenue generated (in %) in Low & middle income in 2008 and the Revenue generated (in %) in Moldova in 2011?
Make the answer very short. -17.38. What is the difference between the Revenue generated (in %) of Ethiopia in 2008 and the Revenue generated (in %) of Korea (Republic) in 2011?
Your answer should be very brief. -12.3. What is the difference between the Revenue generated (in %) of Ethiopia in 2008 and the Revenue generated (in %) of Moldova in 2011?
Ensure brevity in your answer.  -38.1. What is the difference between the Revenue generated (in %) of Korea (Republic) in 2008 and the Revenue generated (in %) of Moldova in 2011?
Your response must be concise. -25.12. What is the difference between the Revenue generated (in %) of Low & middle income in 2009 and the Revenue generated (in %) of Ethiopia in 2010?
Keep it short and to the point. 22.57. What is the difference between the Revenue generated (in %) in Low & middle income in 2009 and the Revenue generated (in %) in Korea (Republic) in 2010?
Your answer should be very brief. 5.08. What is the difference between the Revenue generated (in %) in Low & middle income in 2009 and the Revenue generated (in %) in Moldova in 2010?
Ensure brevity in your answer.  -15.98. What is the difference between the Revenue generated (in %) of Ethiopia in 2009 and the Revenue generated (in %) of Korea (Republic) in 2010?
Provide a succinct answer. -15.84. What is the difference between the Revenue generated (in %) of Ethiopia in 2009 and the Revenue generated (in %) of Moldova in 2010?
Offer a terse response. -36.9. What is the difference between the Revenue generated (in %) in Korea (Republic) in 2009 and the Revenue generated (in %) in Moldova in 2010?
Make the answer very short. -21.93. What is the difference between the Revenue generated (in %) in Low & middle income in 2009 and the Revenue generated (in %) in Ethiopia in 2011?
Provide a succinct answer. 16.26. What is the difference between the Revenue generated (in %) in Low & middle income in 2009 and the Revenue generated (in %) in Korea (Republic) in 2011?
Your answer should be compact. 6.93. What is the difference between the Revenue generated (in %) of Low & middle income in 2009 and the Revenue generated (in %) of Moldova in 2011?
Your answer should be compact. -18.88. What is the difference between the Revenue generated (in %) in Ethiopia in 2009 and the Revenue generated (in %) in Korea (Republic) in 2011?
Your response must be concise. -14. What is the difference between the Revenue generated (in %) of Ethiopia in 2009 and the Revenue generated (in %) of Moldova in 2011?
Your answer should be compact. -39.8. What is the difference between the Revenue generated (in %) in Korea (Republic) in 2009 and the Revenue generated (in %) in Moldova in 2011?
Make the answer very short. -24.82. What is the difference between the Revenue generated (in %) of Low & middle income in 2010 and the Revenue generated (in %) of Ethiopia in 2011?
Keep it short and to the point. 19.42. What is the difference between the Revenue generated (in %) in Low & middle income in 2010 and the Revenue generated (in %) in Korea (Republic) in 2011?
Ensure brevity in your answer.  10.09. What is the difference between the Revenue generated (in %) of Low & middle income in 2010 and the Revenue generated (in %) of Moldova in 2011?
Your answer should be very brief. -15.71. What is the difference between the Revenue generated (in %) of Ethiopia in 2010 and the Revenue generated (in %) of Korea (Republic) in 2011?
Your answer should be very brief. -15.64. What is the difference between the Revenue generated (in %) of Ethiopia in 2010 and the Revenue generated (in %) of Moldova in 2011?
Offer a terse response. -41.45. What is the difference between the Revenue generated (in %) in Korea (Republic) in 2010 and the Revenue generated (in %) in Moldova in 2011?
Provide a succinct answer. -23.96. What is the average Revenue generated (in %) of Low & middle income per year?
Give a very brief answer. 33.62. What is the average Revenue generated (in %) in Ethiopia per year?
Provide a succinct answer. 12.73. What is the average Revenue generated (in %) of Korea (Republic) per year?
Give a very brief answer. 26.62. What is the average Revenue generated (in %) of Moldova per year?
Provide a short and direct response. 48.57. In the year 2004, what is the difference between the Revenue generated (in %) of Low & middle income and Revenue generated (in %) of Ethiopia?
Offer a very short reply. 24.21. In the year 2004, what is the difference between the Revenue generated (in %) in Low & middle income and Revenue generated (in %) in Korea (Republic)?
Make the answer very short. 4.76. In the year 2004, what is the difference between the Revenue generated (in %) in Low & middle income and Revenue generated (in %) in Moldova?
Provide a short and direct response. -13.3. In the year 2004, what is the difference between the Revenue generated (in %) of Ethiopia and Revenue generated (in %) of Korea (Republic)?
Give a very brief answer. -19.45. In the year 2004, what is the difference between the Revenue generated (in %) in Ethiopia and Revenue generated (in %) in Moldova?
Provide a succinct answer. -37.5. In the year 2004, what is the difference between the Revenue generated (in %) in Korea (Republic) and Revenue generated (in %) in Moldova?
Your answer should be compact. -18.05. In the year 2005, what is the difference between the Revenue generated (in %) of Low & middle income and Revenue generated (in %) of Ethiopia?
Your answer should be compact. 22.94. In the year 2005, what is the difference between the Revenue generated (in %) in Low & middle income and Revenue generated (in %) in Korea (Republic)?
Offer a terse response. 5.26. In the year 2005, what is the difference between the Revenue generated (in %) of Low & middle income and Revenue generated (in %) of Moldova?
Provide a succinct answer. -13.68. In the year 2005, what is the difference between the Revenue generated (in %) in Ethiopia and Revenue generated (in %) in Korea (Republic)?
Make the answer very short. -17.68. In the year 2005, what is the difference between the Revenue generated (in %) in Ethiopia and Revenue generated (in %) in Moldova?
Offer a terse response. -36.61. In the year 2005, what is the difference between the Revenue generated (in %) of Korea (Republic) and Revenue generated (in %) of Moldova?
Provide a succinct answer. -18.93. In the year 2006, what is the difference between the Revenue generated (in %) of Low & middle income and Revenue generated (in %) of Ethiopia?
Provide a succinct answer. 15.49. In the year 2006, what is the difference between the Revenue generated (in %) of Low & middle income and Revenue generated (in %) of Korea (Republic)?
Offer a terse response. 5.85. In the year 2006, what is the difference between the Revenue generated (in %) of Low & middle income and Revenue generated (in %) of Moldova?
Provide a succinct answer. -17.5. In the year 2006, what is the difference between the Revenue generated (in %) of Ethiopia and Revenue generated (in %) of Korea (Republic)?
Offer a terse response. -9.64. In the year 2006, what is the difference between the Revenue generated (in %) of Ethiopia and Revenue generated (in %) of Moldova?
Ensure brevity in your answer.  -32.99. In the year 2006, what is the difference between the Revenue generated (in %) in Korea (Republic) and Revenue generated (in %) in Moldova?
Keep it short and to the point. -23.35. In the year 2007, what is the difference between the Revenue generated (in %) in Low & middle income and Revenue generated (in %) in Ethiopia?
Your answer should be very brief. 17.34. In the year 2007, what is the difference between the Revenue generated (in %) in Low & middle income and Revenue generated (in %) in Korea (Republic)?
Your response must be concise. 7.73. In the year 2007, what is the difference between the Revenue generated (in %) of Low & middle income and Revenue generated (in %) of Moldova?
Offer a terse response. -15.84. In the year 2007, what is the difference between the Revenue generated (in %) of Ethiopia and Revenue generated (in %) of Korea (Republic)?
Your answer should be very brief. -9.61. In the year 2007, what is the difference between the Revenue generated (in %) of Ethiopia and Revenue generated (in %) of Moldova?
Your answer should be very brief. -33.18. In the year 2007, what is the difference between the Revenue generated (in %) in Korea (Republic) and Revenue generated (in %) in Moldova?
Offer a very short reply. -23.57. In the year 2008, what is the difference between the Revenue generated (in %) in Low & middle income and Revenue generated (in %) in Ethiopia?
Ensure brevity in your answer.  20.72. In the year 2008, what is the difference between the Revenue generated (in %) in Low & middle income and Revenue generated (in %) in Korea (Republic)?
Ensure brevity in your answer.  7.74. In the year 2008, what is the difference between the Revenue generated (in %) in Low & middle income and Revenue generated (in %) in Moldova?
Your answer should be very brief. -17. In the year 2008, what is the difference between the Revenue generated (in %) of Ethiopia and Revenue generated (in %) of Korea (Republic)?
Ensure brevity in your answer.  -12.98. In the year 2008, what is the difference between the Revenue generated (in %) of Ethiopia and Revenue generated (in %) of Moldova?
Give a very brief answer. -37.71. In the year 2008, what is the difference between the Revenue generated (in %) in Korea (Republic) and Revenue generated (in %) in Moldova?
Provide a succinct answer. -24.73. In the year 2009, what is the difference between the Revenue generated (in %) of Low & middle income and Revenue generated (in %) of Ethiopia?
Offer a very short reply. 20.92. In the year 2009, what is the difference between the Revenue generated (in %) in Low & middle income and Revenue generated (in %) in Korea (Republic)?
Give a very brief answer. 5.95. In the year 2009, what is the difference between the Revenue generated (in %) in Low & middle income and Revenue generated (in %) in Moldova?
Your answer should be compact. -14.17. In the year 2009, what is the difference between the Revenue generated (in %) of Ethiopia and Revenue generated (in %) of Korea (Republic)?
Make the answer very short. -14.98. In the year 2009, what is the difference between the Revenue generated (in %) in Ethiopia and Revenue generated (in %) in Moldova?
Your answer should be very brief. -35.09. In the year 2009, what is the difference between the Revenue generated (in %) in Korea (Republic) and Revenue generated (in %) in Moldova?
Your answer should be compact. -20.12. In the year 2010, what is the difference between the Revenue generated (in %) in Low & middle income and Revenue generated (in %) in Ethiopia?
Your response must be concise. 25.73. In the year 2010, what is the difference between the Revenue generated (in %) of Low & middle income and Revenue generated (in %) of Korea (Republic)?
Your answer should be compact. 8.25. In the year 2010, what is the difference between the Revenue generated (in %) of Low & middle income and Revenue generated (in %) of Moldova?
Make the answer very short. -12.81. In the year 2010, what is the difference between the Revenue generated (in %) of Ethiopia and Revenue generated (in %) of Korea (Republic)?
Your response must be concise. -17.48. In the year 2010, what is the difference between the Revenue generated (in %) of Ethiopia and Revenue generated (in %) of Moldova?
Offer a terse response. -38.55. In the year 2010, what is the difference between the Revenue generated (in %) in Korea (Republic) and Revenue generated (in %) in Moldova?
Make the answer very short. -21.07. In the year 2011, what is the difference between the Revenue generated (in %) of Low & middle income and Revenue generated (in %) of Ethiopia?
Keep it short and to the point. 19.77. In the year 2011, what is the difference between the Revenue generated (in %) of Low & middle income and Revenue generated (in %) of Korea (Republic)?
Provide a succinct answer. 10.44. In the year 2011, what is the difference between the Revenue generated (in %) in Low & middle income and Revenue generated (in %) in Moldova?
Offer a terse response. -15.37. In the year 2011, what is the difference between the Revenue generated (in %) of Ethiopia and Revenue generated (in %) of Korea (Republic)?
Your answer should be very brief. -9.33. In the year 2011, what is the difference between the Revenue generated (in %) in Ethiopia and Revenue generated (in %) in Moldova?
Provide a succinct answer. -35.14. In the year 2011, what is the difference between the Revenue generated (in %) in Korea (Republic) and Revenue generated (in %) in Moldova?
Provide a short and direct response. -25.81. What is the ratio of the Revenue generated (in %) in Low & middle income in 2004 to that in 2005?
Your answer should be compact. 1.02. What is the ratio of the Revenue generated (in %) in Ethiopia in 2004 to that in 2005?
Make the answer very short. 0.95. What is the ratio of the Revenue generated (in %) in Korea (Republic) in 2004 to that in 2005?
Make the answer very short. 1.04. What is the ratio of the Revenue generated (in %) of Moldova in 2004 to that in 2005?
Offer a terse response. 1.01. What is the ratio of the Revenue generated (in %) in Low & middle income in 2004 to that in 2006?
Offer a very short reply. 1.05. What is the ratio of the Revenue generated (in %) of Ethiopia in 2004 to that in 2006?
Your answer should be very brief. 0.59. What is the ratio of the Revenue generated (in %) of Korea (Republic) in 2004 to that in 2006?
Ensure brevity in your answer.  1.11. What is the ratio of the Revenue generated (in %) in Moldova in 2004 to that in 2006?
Provide a succinct answer. 0.95. What is the ratio of the Revenue generated (in %) in Low & middle income in 2004 to that in 2007?
Ensure brevity in your answer.  1.04. What is the ratio of the Revenue generated (in %) in Ethiopia in 2004 to that in 2007?
Keep it short and to the point. 0.64. What is the ratio of the Revenue generated (in %) of Korea (Republic) in 2004 to that in 2007?
Ensure brevity in your answer.  1.17. What is the ratio of the Revenue generated (in %) in Moldova in 2004 to that in 2007?
Your response must be concise. 0.97. What is the ratio of the Revenue generated (in %) in Low & middle income in 2004 to that in 2008?
Provide a short and direct response. 1.03. What is the ratio of the Revenue generated (in %) of Ethiopia in 2004 to that in 2008?
Your response must be concise. 0.8. What is the ratio of the Revenue generated (in %) in Korea (Republic) in 2004 to that in 2008?
Your answer should be compact. 1.16. What is the ratio of the Revenue generated (in %) in Moldova in 2004 to that in 2008?
Offer a terse response. 0.95. What is the ratio of the Revenue generated (in %) in Low & middle income in 2004 to that in 2009?
Make the answer very short. 1.08. What is the ratio of the Revenue generated (in %) in Ethiopia in 2004 to that in 2009?
Keep it short and to the point. 0.93. What is the ratio of the Revenue generated (in %) of Korea (Republic) in 2004 to that in 2009?
Provide a succinct answer. 1.14. What is the ratio of the Revenue generated (in %) in Moldova in 2004 to that in 2009?
Your answer should be compact. 1.04. What is the ratio of the Revenue generated (in %) in Ethiopia in 2004 to that in 2010?
Make the answer very short. 1.09. What is the ratio of the Revenue generated (in %) of Korea (Republic) in 2004 to that in 2010?
Your answer should be very brief. 1.11. What is the ratio of the Revenue generated (in %) of Low & middle income in 2004 to that in 2011?
Ensure brevity in your answer.  0.97. What is the ratio of the Revenue generated (in %) in Ethiopia in 2004 to that in 2011?
Your answer should be very brief. 0.65. What is the ratio of the Revenue generated (in %) in Korea (Republic) in 2004 to that in 2011?
Your response must be concise. 1.19. What is the ratio of the Revenue generated (in %) in Moldova in 2004 to that in 2011?
Provide a succinct answer. 0.94. What is the ratio of the Revenue generated (in %) of Low & middle income in 2005 to that in 2006?
Provide a succinct answer. 1.03. What is the ratio of the Revenue generated (in %) of Ethiopia in 2005 to that in 2006?
Offer a terse response. 0.62. What is the ratio of the Revenue generated (in %) in Korea (Republic) in 2005 to that in 2006?
Provide a succinct answer. 1.06. What is the ratio of the Revenue generated (in %) in Moldova in 2005 to that in 2006?
Your answer should be compact. 0.94. What is the ratio of the Revenue generated (in %) of Ethiopia in 2005 to that in 2007?
Your answer should be very brief. 0.68. What is the ratio of the Revenue generated (in %) in Korea (Republic) in 2005 to that in 2007?
Your answer should be very brief. 1.12. What is the ratio of the Revenue generated (in %) in Moldova in 2005 to that in 2007?
Offer a very short reply. 0.97. What is the ratio of the Revenue generated (in %) in Low & middle income in 2005 to that in 2008?
Keep it short and to the point. 1.01. What is the ratio of the Revenue generated (in %) in Ethiopia in 2005 to that in 2008?
Make the answer very short. 0.85. What is the ratio of the Revenue generated (in %) of Korea (Republic) in 2005 to that in 2008?
Offer a very short reply. 1.11. What is the ratio of the Revenue generated (in %) of Moldova in 2005 to that in 2008?
Ensure brevity in your answer.  0.94. What is the ratio of the Revenue generated (in %) in Low & middle income in 2005 to that in 2009?
Ensure brevity in your answer.  1.06. What is the ratio of the Revenue generated (in %) of Ethiopia in 2005 to that in 2009?
Your answer should be very brief. 0.98. What is the ratio of the Revenue generated (in %) of Korea (Republic) in 2005 to that in 2009?
Offer a very short reply. 1.09. What is the ratio of the Revenue generated (in %) of Moldova in 2005 to that in 2009?
Your response must be concise. 1.03. What is the ratio of the Revenue generated (in %) in Ethiopia in 2005 to that in 2010?
Provide a short and direct response. 1.15. What is the ratio of the Revenue generated (in %) of Korea (Republic) in 2005 to that in 2010?
Your answer should be compact. 1.06. What is the ratio of the Revenue generated (in %) of Moldova in 2005 to that in 2010?
Your response must be concise. 0.99. What is the ratio of the Revenue generated (in %) in Low & middle income in 2005 to that in 2011?
Your answer should be very brief. 0.95. What is the ratio of the Revenue generated (in %) in Ethiopia in 2005 to that in 2011?
Your answer should be very brief. 0.68. What is the ratio of the Revenue generated (in %) in Korea (Republic) in 2005 to that in 2011?
Give a very brief answer. 1.14. What is the ratio of the Revenue generated (in %) in Moldova in 2005 to that in 2011?
Provide a succinct answer. 0.93. What is the ratio of the Revenue generated (in %) of Low & middle income in 2006 to that in 2007?
Provide a short and direct response. 0.98. What is the ratio of the Revenue generated (in %) in Ethiopia in 2006 to that in 2007?
Offer a terse response. 1.08. What is the ratio of the Revenue generated (in %) of Korea (Republic) in 2006 to that in 2007?
Provide a succinct answer. 1.05. What is the ratio of the Revenue generated (in %) in Moldova in 2006 to that in 2007?
Offer a very short reply. 1.02. What is the ratio of the Revenue generated (in %) of Low & middle income in 2006 to that in 2008?
Your answer should be compact. 0.98. What is the ratio of the Revenue generated (in %) of Ethiopia in 2006 to that in 2008?
Provide a succinct answer. 1.35. What is the ratio of the Revenue generated (in %) in Korea (Republic) in 2006 to that in 2008?
Give a very brief answer. 1.04. What is the ratio of the Revenue generated (in %) in Moldova in 2006 to that in 2008?
Your response must be concise. 0.99. What is the ratio of the Revenue generated (in %) in Low & middle income in 2006 to that in 2009?
Give a very brief answer. 1.02. What is the ratio of the Revenue generated (in %) in Ethiopia in 2006 to that in 2009?
Make the answer very short. 1.57. What is the ratio of the Revenue generated (in %) in Korea (Republic) in 2006 to that in 2009?
Provide a short and direct response. 1.03. What is the ratio of the Revenue generated (in %) of Moldova in 2006 to that in 2009?
Provide a short and direct response. 1.09. What is the ratio of the Revenue generated (in %) of Low & middle income in 2006 to that in 2010?
Ensure brevity in your answer.  0.93. What is the ratio of the Revenue generated (in %) in Ethiopia in 2006 to that in 2010?
Your answer should be compact. 1.84. What is the ratio of the Revenue generated (in %) of Korea (Republic) in 2006 to that in 2010?
Offer a very short reply. 1. What is the ratio of the Revenue generated (in %) in Moldova in 2006 to that in 2010?
Offer a terse response. 1.05. What is the ratio of the Revenue generated (in %) of Low & middle income in 2006 to that in 2011?
Ensure brevity in your answer.  0.92. What is the ratio of the Revenue generated (in %) in Ethiopia in 2006 to that in 2011?
Your answer should be very brief. 1.1. What is the ratio of the Revenue generated (in %) in Korea (Republic) in 2006 to that in 2011?
Your answer should be very brief. 1.07. What is the ratio of the Revenue generated (in %) of Moldova in 2006 to that in 2011?
Ensure brevity in your answer.  0.99. What is the ratio of the Revenue generated (in %) in Ethiopia in 2007 to that in 2008?
Make the answer very short. 1.25. What is the ratio of the Revenue generated (in %) in Moldova in 2007 to that in 2008?
Ensure brevity in your answer.  0.97. What is the ratio of the Revenue generated (in %) of Ethiopia in 2007 to that in 2009?
Offer a very short reply. 1.45. What is the ratio of the Revenue generated (in %) in Korea (Republic) in 2007 to that in 2009?
Your response must be concise. 0.98. What is the ratio of the Revenue generated (in %) of Moldova in 2007 to that in 2009?
Provide a succinct answer. 1.06. What is the ratio of the Revenue generated (in %) of Low & middle income in 2007 to that in 2010?
Keep it short and to the point. 0.95. What is the ratio of the Revenue generated (in %) of Ethiopia in 2007 to that in 2010?
Make the answer very short. 1.7. What is the ratio of the Revenue generated (in %) of Korea (Republic) in 2007 to that in 2010?
Your answer should be compact. 0.95. What is the ratio of the Revenue generated (in %) in Moldova in 2007 to that in 2010?
Give a very brief answer. 1.02. What is the ratio of the Revenue generated (in %) in Low & middle income in 2007 to that in 2011?
Keep it short and to the point. 0.94. What is the ratio of the Revenue generated (in %) in Ethiopia in 2007 to that in 2011?
Your response must be concise. 1.01. What is the ratio of the Revenue generated (in %) of Korea (Republic) in 2007 to that in 2011?
Make the answer very short. 1.02. What is the ratio of the Revenue generated (in %) in Moldova in 2007 to that in 2011?
Keep it short and to the point. 0.97. What is the ratio of the Revenue generated (in %) in Low & middle income in 2008 to that in 2009?
Your response must be concise. 1.05. What is the ratio of the Revenue generated (in %) of Ethiopia in 2008 to that in 2009?
Offer a very short reply. 1.16. What is the ratio of the Revenue generated (in %) in Moldova in 2008 to that in 2009?
Provide a short and direct response. 1.09. What is the ratio of the Revenue generated (in %) in Low & middle income in 2008 to that in 2010?
Offer a terse response. 0.95. What is the ratio of the Revenue generated (in %) of Ethiopia in 2008 to that in 2010?
Offer a terse response. 1.36. What is the ratio of the Revenue generated (in %) of Korea (Republic) in 2008 to that in 2010?
Keep it short and to the point. 0.96. What is the ratio of the Revenue generated (in %) in Moldova in 2008 to that in 2010?
Make the answer very short. 1.05. What is the ratio of the Revenue generated (in %) in Low & middle income in 2008 to that in 2011?
Offer a very short reply. 0.94. What is the ratio of the Revenue generated (in %) of Ethiopia in 2008 to that in 2011?
Give a very brief answer. 0.81. What is the ratio of the Revenue generated (in %) of Korea (Republic) in 2008 to that in 2011?
Your response must be concise. 1.03. What is the ratio of the Revenue generated (in %) of Moldova in 2008 to that in 2011?
Your answer should be compact. 0.99. What is the ratio of the Revenue generated (in %) of Low & middle income in 2009 to that in 2010?
Ensure brevity in your answer.  0.91. What is the ratio of the Revenue generated (in %) in Ethiopia in 2009 to that in 2010?
Offer a terse response. 1.18. What is the ratio of the Revenue generated (in %) in Korea (Republic) in 2009 to that in 2010?
Offer a terse response. 0.97. What is the ratio of the Revenue generated (in %) of Moldova in 2009 to that in 2010?
Offer a terse response. 0.96. What is the ratio of the Revenue generated (in %) of Low & middle income in 2009 to that in 2011?
Provide a short and direct response. 0.9. What is the ratio of the Revenue generated (in %) of Ethiopia in 2009 to that in 2011?
Provide a short and direct response. 0.7. What is the ratio of the Revenue generated (in %) of Korea (Republic) in 2009 to that in 2011?
Give a very brief answer. 1.04. What is the ratio of the Revenue generated (in %) of Moldova in 2009 to that in 2011?
Ensure brevity in your answer.  0.91. What is the ratio of the Revenue generated (in %) in Low & middle income in 2010 to that in 2011?
Give a very brief answer. 0.99. What is the ratio of the Revenue generated (in %) of Ethiopia in 2010 to that in 2011?
Provide a succinct answer. 0.59. What is the ratio of the Revenue generated (in %) of Korea (Republic) in 2010 to that in 2011?
Your answer should be compact. 1.07. What is the ratio of the Revenue generated (in %) of Moldova in 2010 to that in 2011?
Keep it short and to the point. 0.94. What is the difference between the highest and the second highest Revenue generated (in %) of Low & middle income?
Offer a terse response. 0.35. What is the difference between the highest and the second highest Revenue generated (in %) in Ethiopia?
Make the answer very short. 1.3. What is the difference between the highest and the second highest Revenue generated (in %) in Korea (Republic)?
Provide a succinct answer. 1.24. What is the difference between the highest and the second highest Revenue generated (in %) of Moldova?
Your answer should be compact. 0.39. What is the difference between the highest and the lowest Revenue generated (in %) of Low & middle income?
Make the answer very short. 3.51. What is the difference between the highest and the lowest Revenue generated (in %) of Ethiopia?
Your response must be concise. 7.8. What is the difference between the highest and the lowest Revenue generated (in %) of Korea (Republic)?
Your response must be concise. 4.67. What is the difference between the highest and the lowest Revenue generated (in %) of Moldova?
Give a very brief answer. 4.71. 